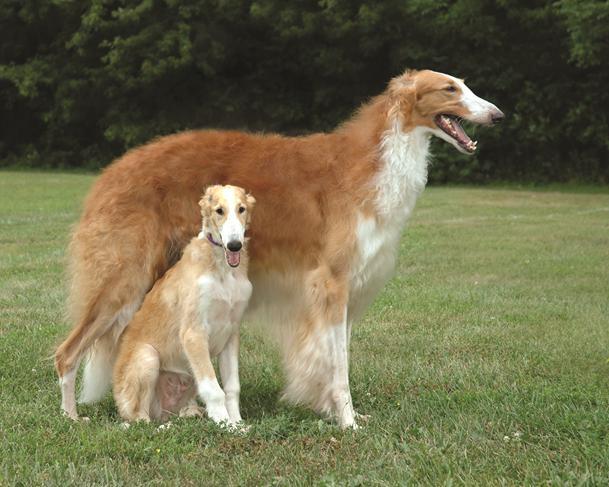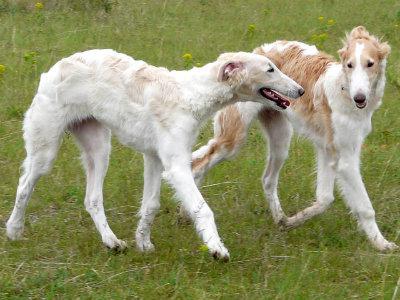The first image is the image on the left, the second image is the image on the right. For the images shown, is this caption "There are two dogs" true? Answer yes or no. No. 